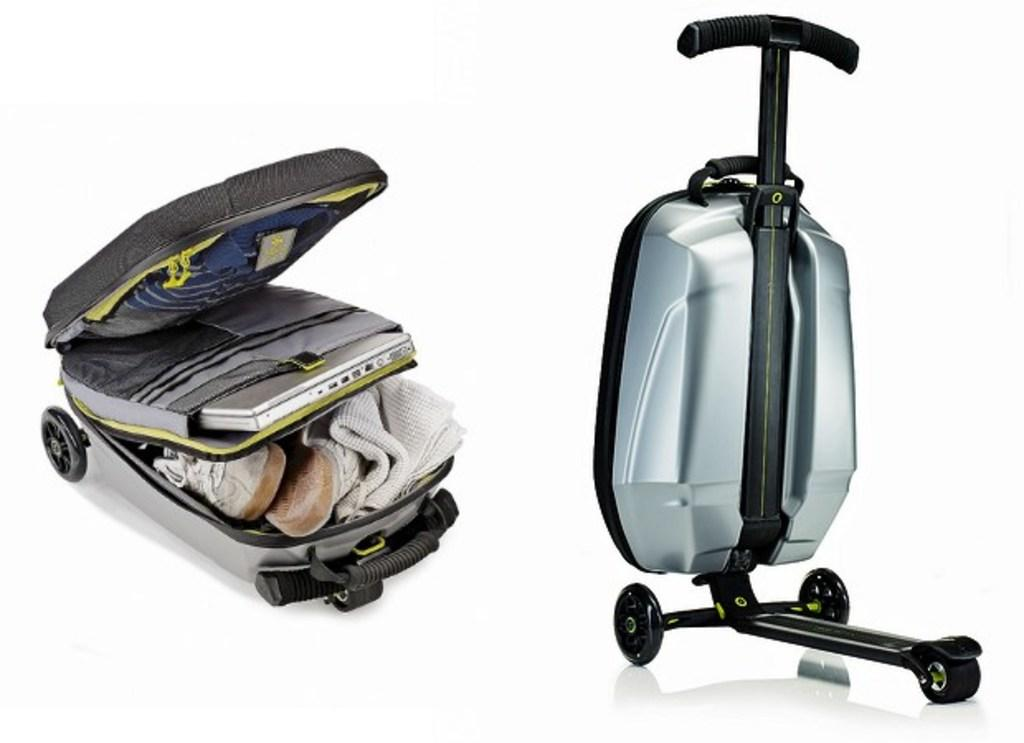What object is visible in the image that can be used for carrying items? There is a luggage box in the image that can be used for carrying items. What items can be found inside the luggage box? The luggage box contains a towel, shoes, a laptop, and a T-shirt. How can the luggage box be easily moved? The luggage box has wheels, which makes it easy to move. Is there any design or image on the luggage box? Yes, there is an image on the right side of the luggage box. What type of eggs are being protested against in the image? There is no protest or eggs present in the image; it features a luggage box with various items inside. Is there a mask visible in the image? There is no mask present in the image; it only shows a luggage box with an image on the right side. 